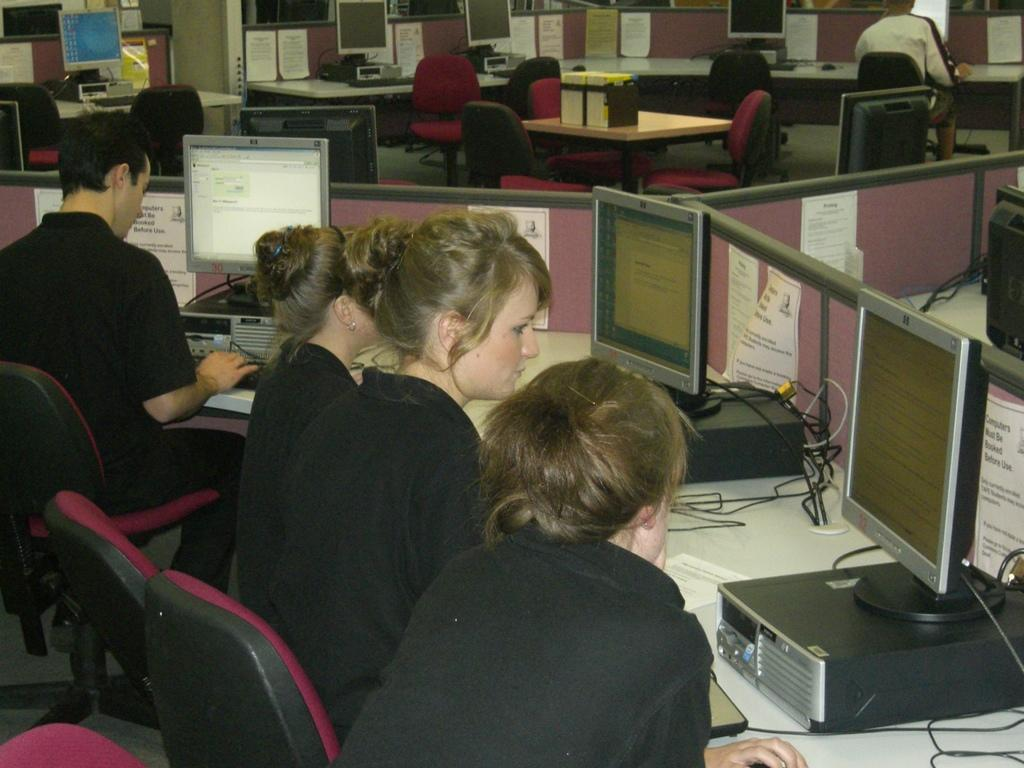What type of structures are visible in the image? There are cabins in the image. What are the people in the image doing? People are sitting and working on computers in the image. Can you describe the seating arrangement in the image? At the top of the image, there are chairs. What is on the table in the image? There is a table in the image with papers and monitors visible. What might be used for organizing papers in the image? There is a file holder in the image. What type of orange can be seen hanging from the trees in the image? There are no trees or oranges present in the image; it features cabins with people working on computers. Can you tell me how many stores are visible in the image? There are no stores visible in the image; it features cabins with people working on computers. 